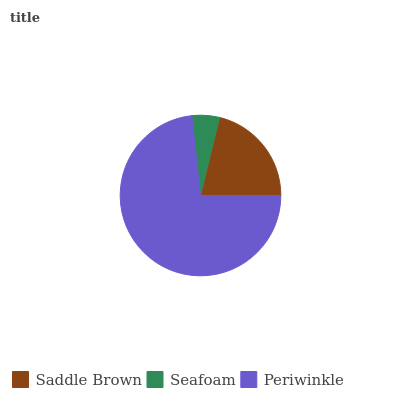Is Seafoam the minimum?
Answer yes or no. Yes. Is Periwinkle the maximum?
Answer yes or no. Yes. Is Periwinkle the minimum?
Answer yes or no. No. Is Seafoam the maximum?
Answer yes or no. No. Is Periwinkle greater than Seafoam?
Answer yes or no. Yes. Is Seafoam less than Periwinkle?
Answer yes or no. Yes. Is Seafoam greater than Periwinkle?
Answer yes or no. No. Is Periwinkle less than Seafoam?
Answer yes or no. No. Is Saddle Brown the high median?
Answer yes or no. Yes. Is Saddle Brown the low median?
Answer yes or no. Yes. Is Seafoam the high median?
Answer yes or no. No. Is Periwinkle the low median?
Answer yes or no. No. 